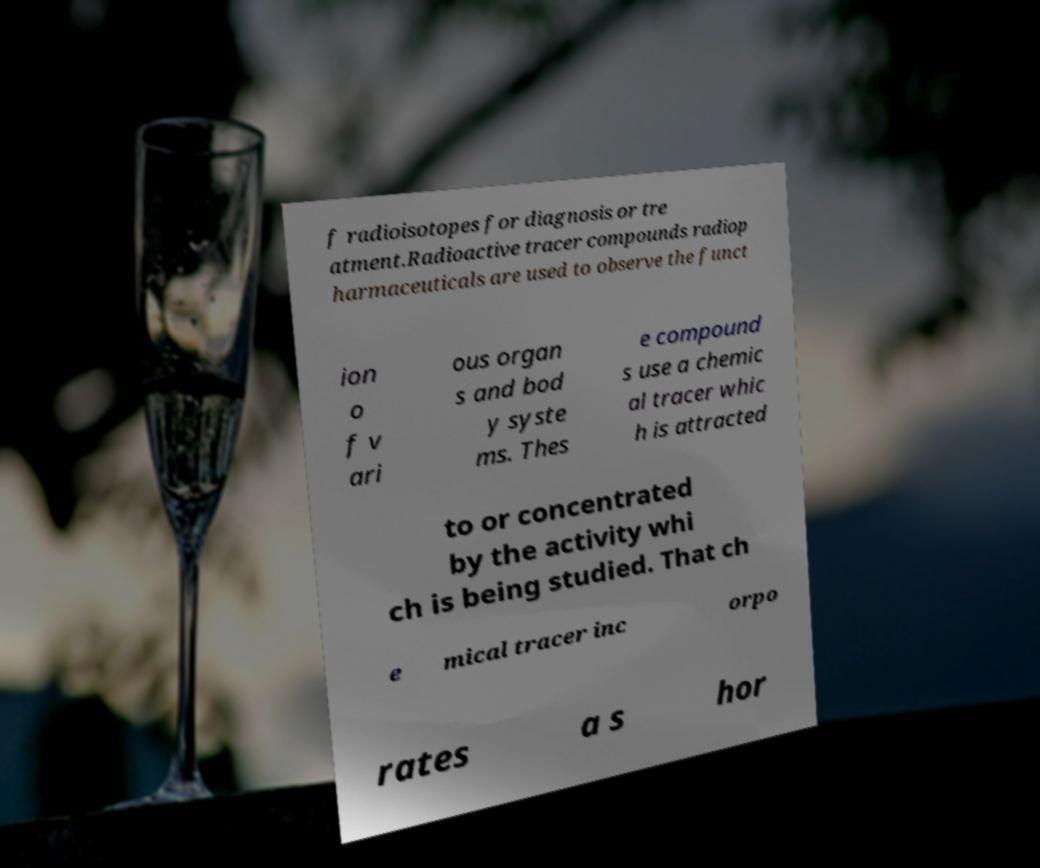Could you extract and type out the text from this image? f radioisotopes for diagnosis or tre atment.Radioactive tracer compounds radiop harmaceuticals are used to observe the funct ion o f v ari ous organ s and bod y syste ms. Thes e compound s use a chemic al tracer whic h is attracted to or concentrated by the activity whi ch is being studied. That ch e mical tracer inc orpo rates a s hor 